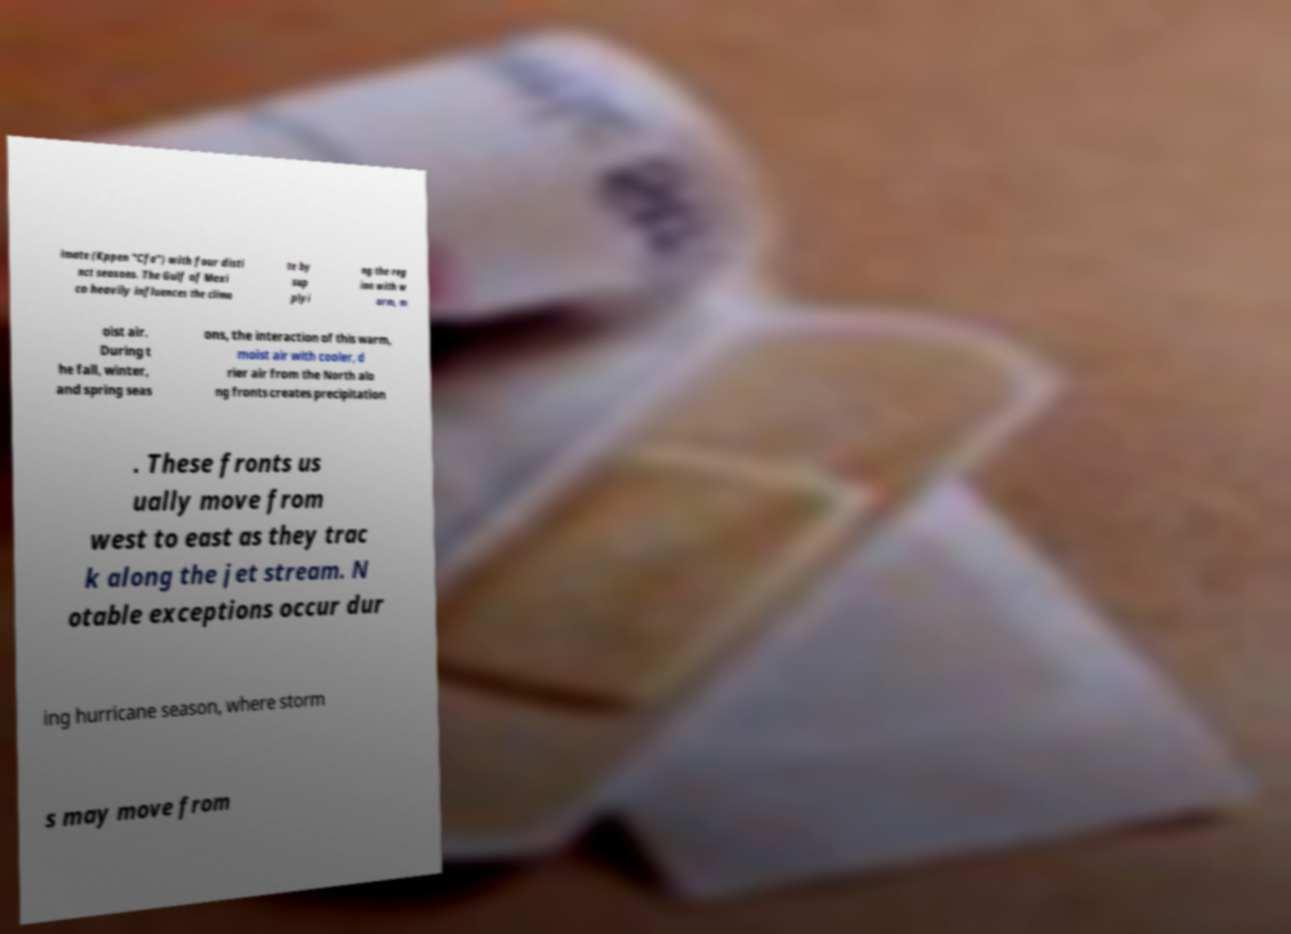Could you extract and type out the text from this image? imate (Kppen "Cfa") with four disti nct seasons. The Gulf of Mexi co heavily influences the clima te by sup plyi ng the reg ion with w arm, m oist air. During t he fall, winter, and spring seas ons, the interaction of this warm, moist air with cooler, d rier air from the North alo ng fronts creates precipitation . These fronts us ually move from west to east as they trac k along the jet stream. N otable exceptions occur dur ing hurricane season, where storm s may move from 